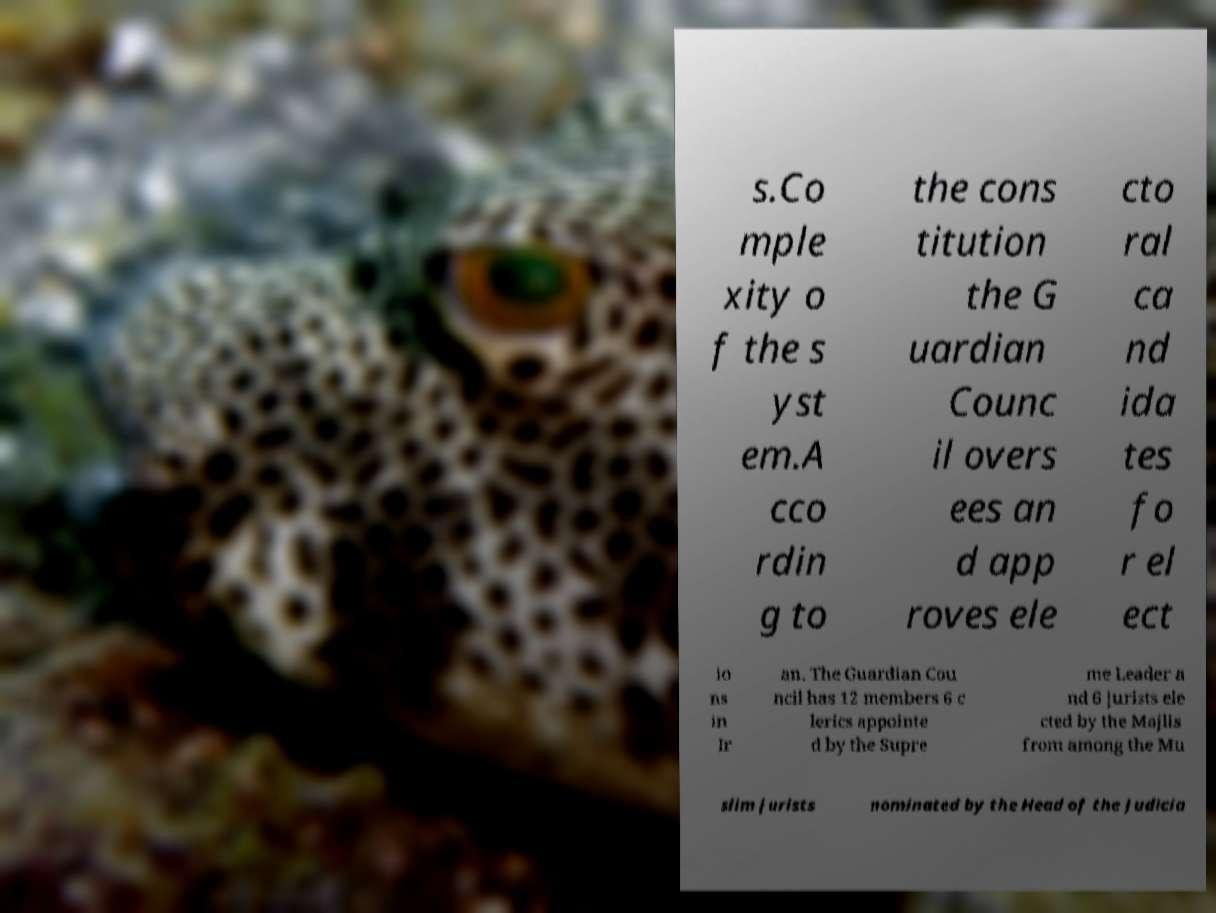Please identify and transcribe the text found in this image. s.Co mple xity o f the s yst em.A cco rdin g to the cons titution the G uardian Counc il overs ees an d app roves ele cto ral ca nd ida tes fo r el ect io ns in Ir an. The Guardian Cou ncil has 12 members 6 c lerics appointe d by the Supre me Leader a nd 6 jurists ele cted by the Majlis from among the Mu slim jurists nominated by the Head of the Judicia 